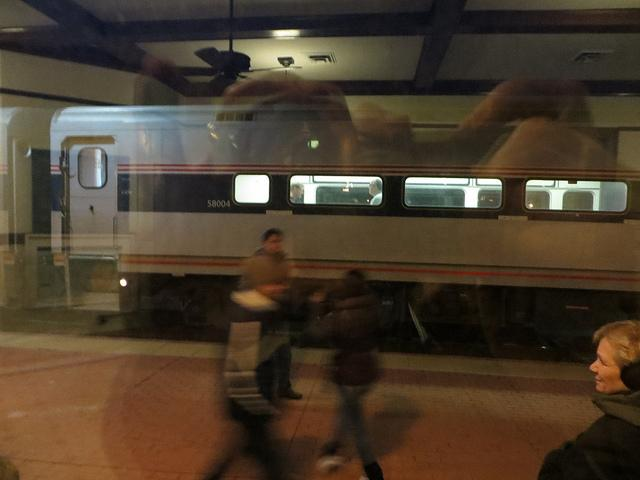How many people are walking around in the train station?

Choices:
A) four
B) one
C) three
D) two three 